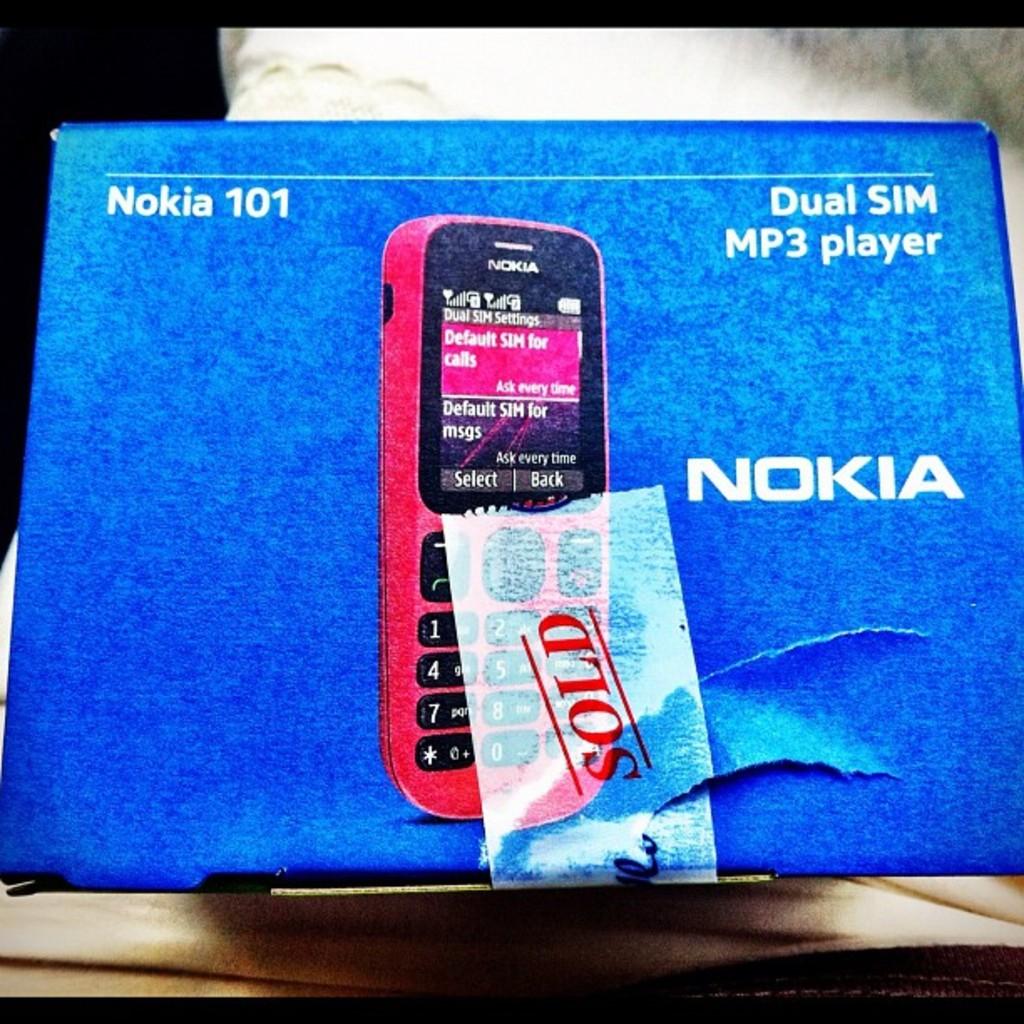What brand of phone is this?
Provide a succinct answer. Nokia. 